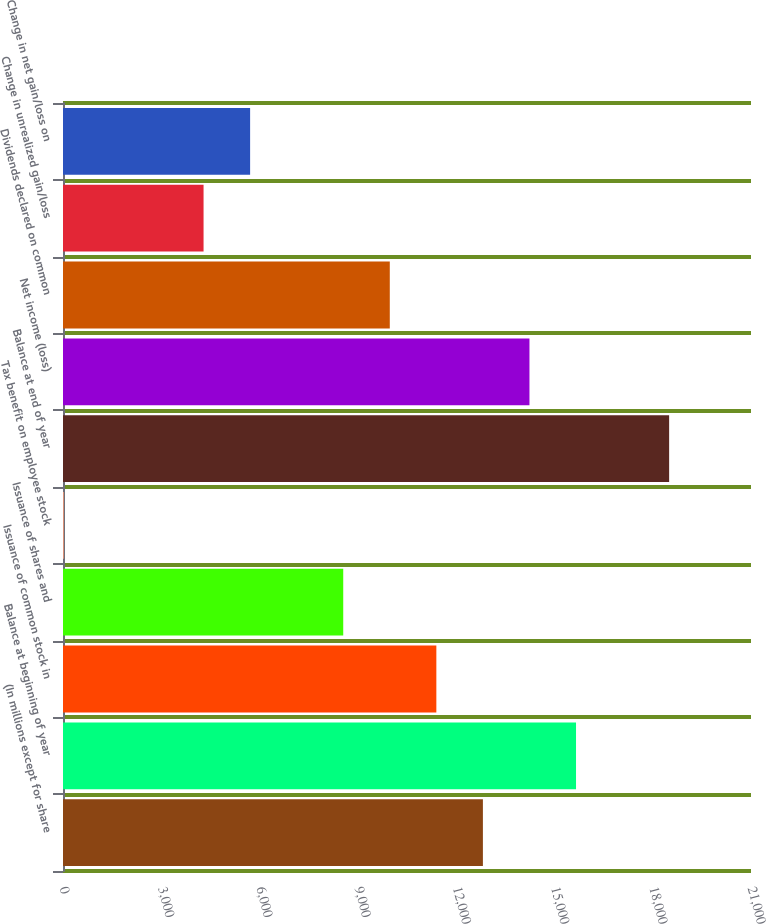Convert chart. <chart><loc_0><loc_0><loc_500><loc_500><bar_chart><fcel>(In millions except for share<fcel>Balance at beginning of year<fcel>Issuance of common stock in<fcel>Issuance of shares and<fcel>Tax benefit on employee stock<fcel>Balance at end of year<fcel>Net income (loss)<fcel>Dividends declared on common<fcel>Change in unrealized gain/loss<fcel>Change in net gain/loss on<nl><fcel>12816.9<fcel>15659.1<fcel>11395.8<fcel>8553.6<fcel>27<fcel>18501.3<fcel>14238<fcel>9974.7<fcel>4290.3<fcel>5711.4<nl></chart> 